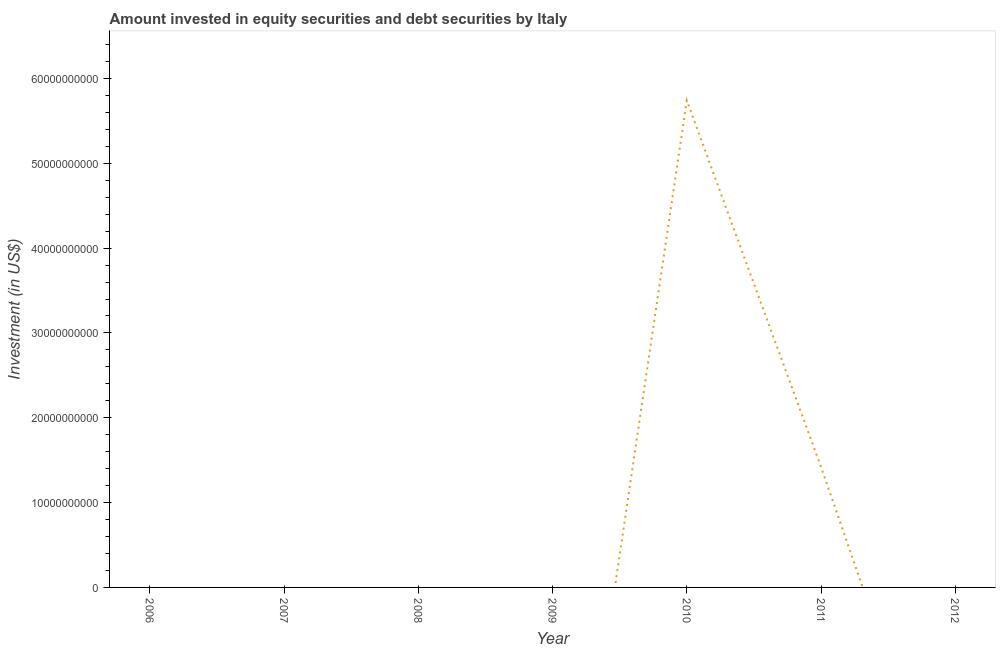What is the portfolio investment in 2012?
Your response must be concise. 0. Across all years, what is the maximum portfolio investment?
Keep it short and to the point. 5.74e+1. Across all years, what is the minimum portfolio investment?
Provide a succinct answer. 0. In which year was the portfolio investment maximum?
Your answer should be very brief. 2010. What is the sum of the portfolio investment?
Your answer should be compact. 7.16e+1. What is the difference between the portfolio investment in 2010 and 2011?
Your response must be concise. 4.32e+1. What is the average portfolio investment per year?
Make the answer very short. 1.02e+1. In how many years, is the portfolio investment greater than 40000000000 US$?
Provide a short and direct response. 1. What is the difference between the highest and the lowest portfolio investment?
Your response must be concise. 5.74e+1. What is the difference between two consecutive major ticks on the Y-axis?
Make the answer very short. 1.00e+1. Does the graph contain any zero values?
Provide a short and direct response. Yes. Does the graph contain grids?
Keep it short and to the point. No. What is the title of the graph?
Provide a short and direct response. Amount invested in equity securities and debt securities by Italy. What is the label or title of the Y-axis?
Provide a succinct answer. Investment (in US$). What is the Investment (in US$) in 2007?
Your response must be concise. 0. What is the Investment (in US$) of 2010?
Offer a very short reply. 5.74e+1. What is the Investment (in US$) in 2011?
Offer a very short reply. 1.42e+1. What is the difference between the Investment (in US$) in 2010 and 2011?
Give a very brief answer. 4.32e+1. What is the ratio of the Investment (in US$) in 2010 to that in 2011?
Offer a terse response. 4.04. 